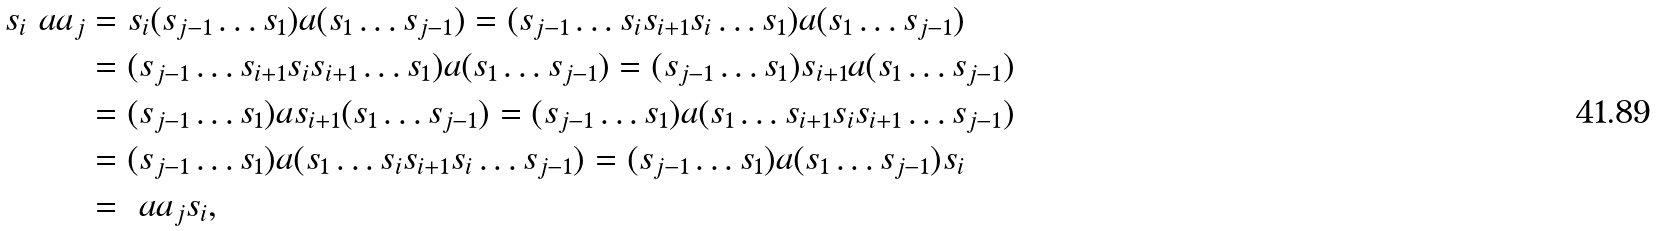Convert formula to latex. <formula><loc_0><loc_0><loc_500><loc_500>s _ { i } \ a a _ { j } & = s _ { i } ( s _ { j - 1 } \dots s _ { 1 } ) a ( s _ { 1 } \dots s _ { j - 1 } ) = ( s _ { j - 1 } \dots s _ { i } s _ { i + 1 } s _ { i } \dots s _ { 1 } ) a ( s _ { 1 } \dots s _ { j - 1 } ) \\ & = ( s _ { j - 1 } \dots s _ { i + 1 } s _ { i } s _ { i + 1 } \dots s _ { 1 } ) a ( s _ { 1 } \dots s _ { j - 1 } ) = ( s _ { j - 1 } \dots s _ { 1 } ) s _ { i + 1 } a ( s _ { 1 } \dots s _ { j - 1 } ) \\ & = ( s _ { j - 1 } \dots s _ { 1 } ) a s _ { i + 1 } ( s _ { 1 } \dots s _ { j - 1 } ) = ( s _ { j - 1 } \dots s _ { 1 } ) a ( s _ { 1 } \dots s _ { i + 1 } s _ { i } s _ { i + 1 } \dots s _ { j - 1 } ) \\ & = ( s _ { j - 1 } \dots s _ { 1 } ) a ( s _ { 1 } \dots s _ { i } s _ { i + 1 } s _ { i } \dots s _ { j - 1 } ) = ( s _ { j - 1 } \dots s _ { 1 } ) a ( s _ { 1 } \dots s _ { j - 1 } ) s _ { i } \\ & = \ a a _ { j } s _ { i } ,</formula> 